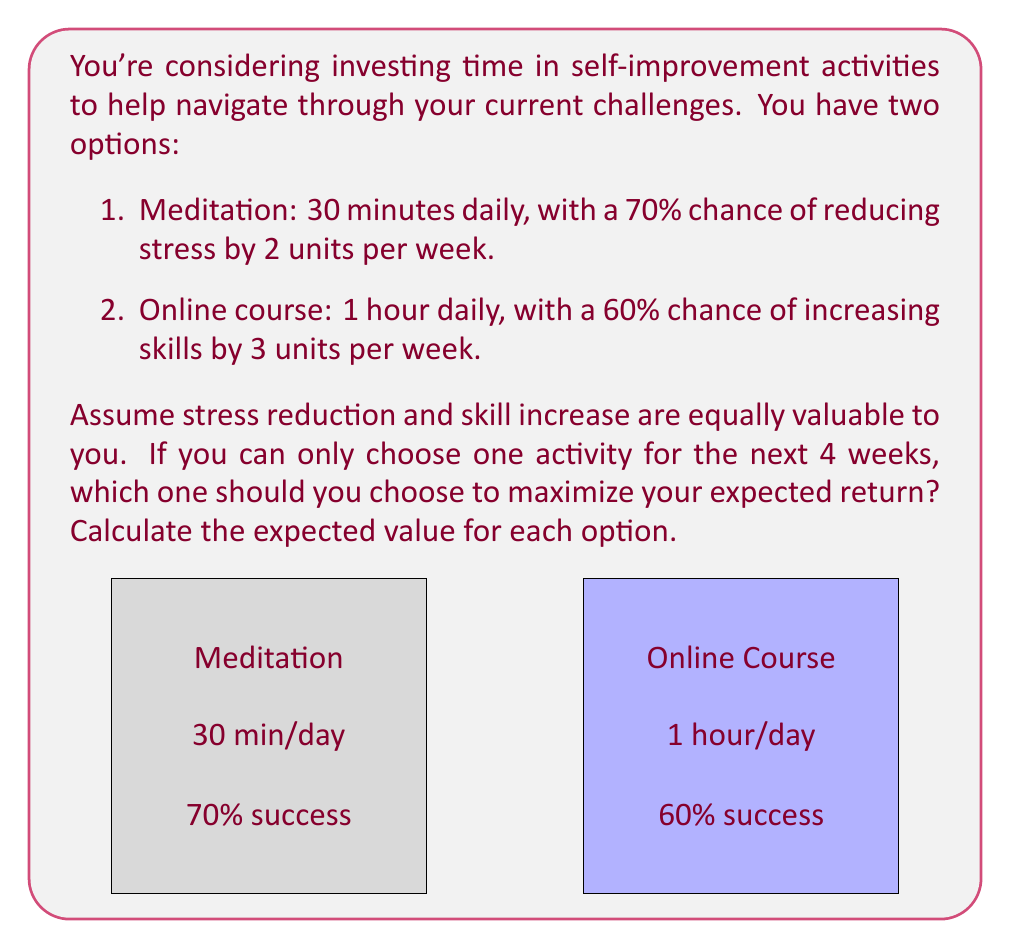Teach me how to tackle this problem. Let's calculate the expected value for each option:

1. Meditation:
   - Time invested: 30 minutes * 7 days * 4 weeks = 840 minutes
   - Probability of success: 70% = 0.7
   - Potential benefit: 2 units/week * 4 weeks = 8 units
   - Expected value: $EV_{meditation} = 0.7 * 8 = 5.6$ units

2. Online course:
   - Time invested: 60 minutes * 7 days * 4 weeks = 1680 minutes
   - Probability of success: 60% = 0.6
   - Potential benefit: 3 units/week * 4 weeks = 12 units
   - Expected value: $EV_{course} = 0.6 * 12 = 7.2$ units

To compare these options fairly, we need to account for the different time investments:

1. Meditation: $\frac{5.6 \text{ units}}{840 \text{ minutes}} \approx 0.00667 \text{ units/minute}$
2. Online course: $\frac{7.2 \text{ units}}{1680 \text{ minutes}} \approx 0.00429 \text{ units/minute}$

Therefore, meditation offers a higher expected return per minute invested.
Answer: Choose meditation: $0.00667 \text{ units/minute} > 0.00429 \text{ units/minute}$ 